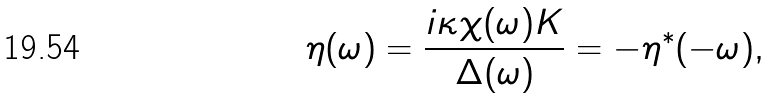Convert formula to latex. <formula><loc_0><loc_0><loc_500><loc_500>\eta ( \omega ) = \frac { i \kappa \chi ( \omega ) K } { \Delta ( \omega ) } = - \eta ^ { * } ( - \omega ) ,</formula> 